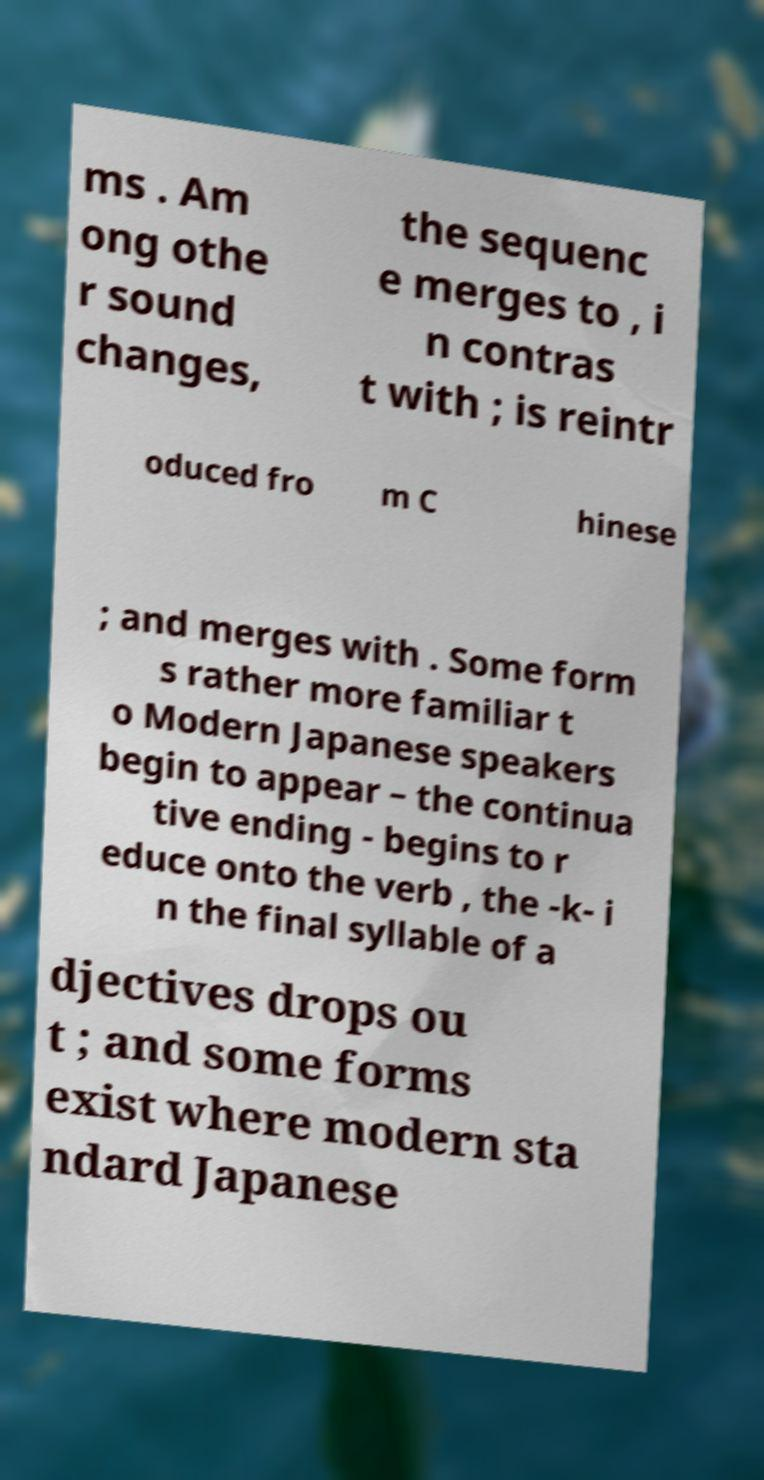Can you accurately transcribe the text from the provided image for me? ms . Am ong othe r sound changes, the sequenc e merges to , i n contras t with ; is reintr oduced fro m C hinese ; and merges with . Some form s rather more familiar t o Modern Japanese speakers begin to appear – the continua tive ending - begins to r educe onto the verb , the -k- i n the final syllable of a djectives drops ou t ; and some forms exist where modern sta ndard Japanese 